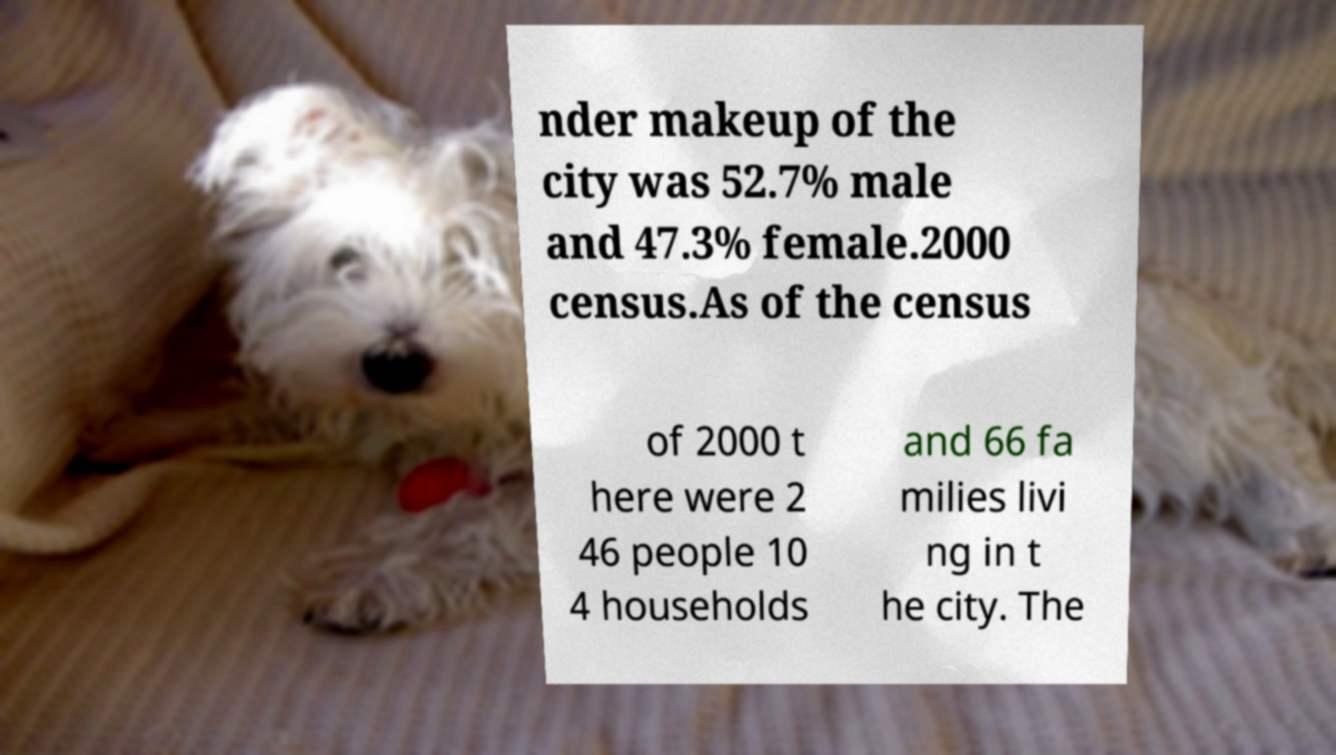Please identify and transcribe the text found in this image. nder makeup of the city was 52.7% male and 47.3% female.2000 census.As of the census of 2000 t here were 2 46 people 10 4 households and 66 fa milies livi ng in t he city. The 